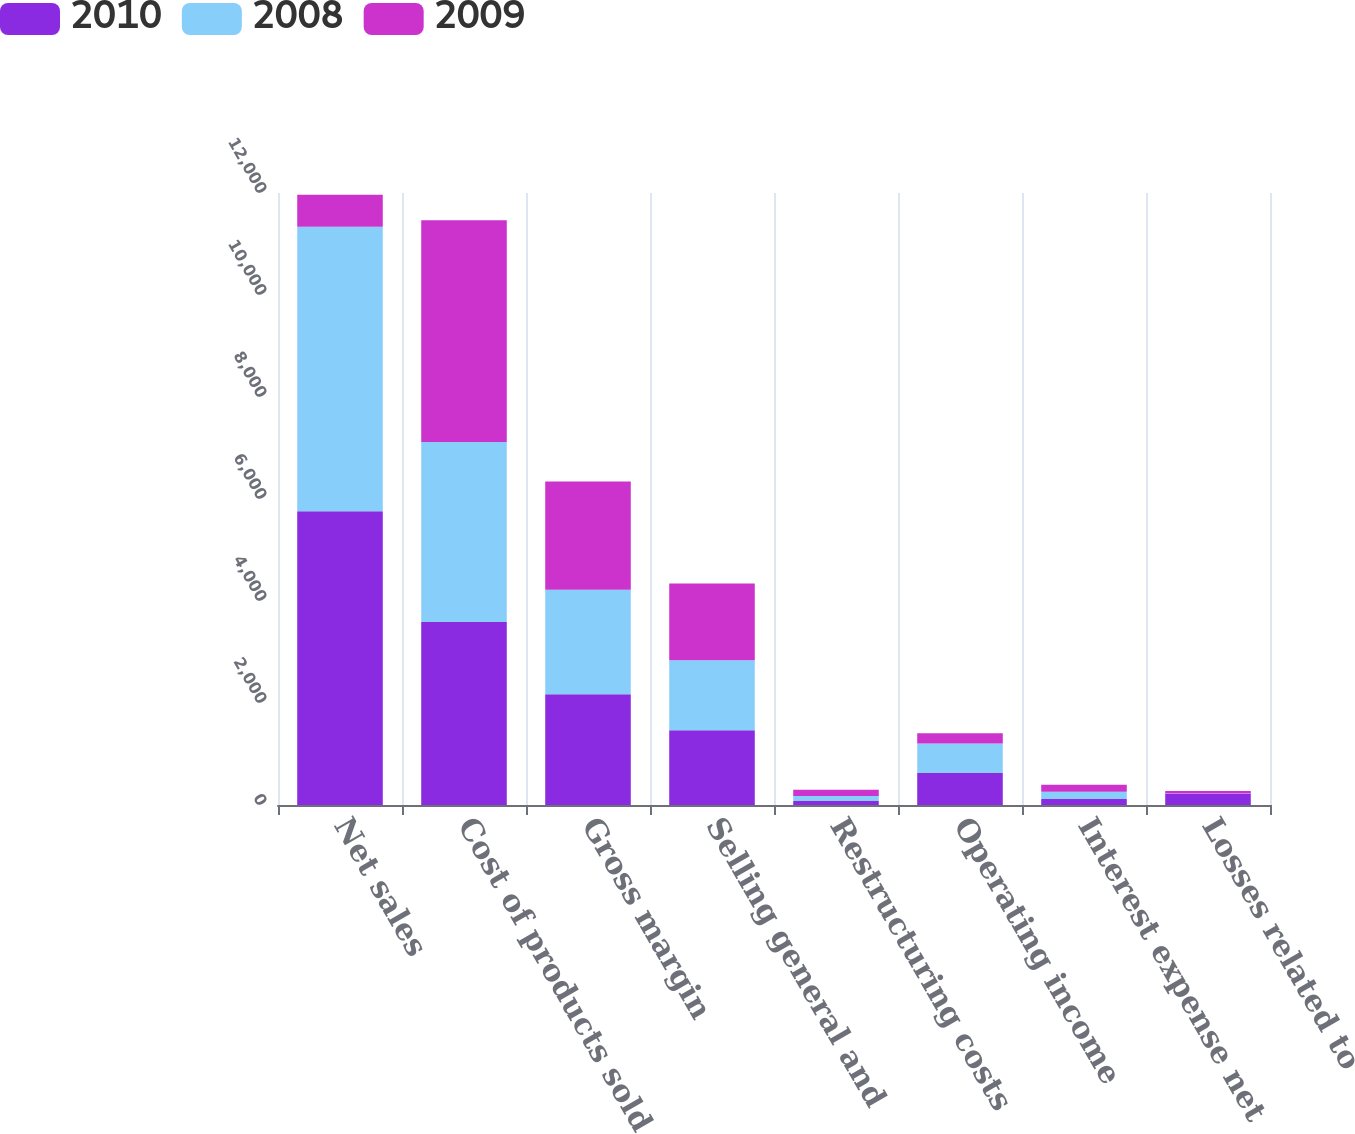Convert chart. <chart><loc_0><loc_0><loc_500><loc_500><stacked_bar_chart><ecel><fcel>Net sales<fcel>Cost of products sold<fcel>Gross margin<fcel>Selling general and<fcel>Restructuring costs<fcel>Operating income<fcel>Interest expense net<fcel>Losses related to<nl><fcel>2010<fcel>5759.2<fcel>3588.4<fcel>2170.8<fcel>1463.4<fcel>77.5<fcel>629.9<fcel>118.4<fcel>218.6<nl><fcel>2008<fcel>5577.6<fcel>3528.1<fcel>2049.5<fcel>1374.6<fcel>100<fcel>574.9<fcel>140<fcel>4.7<nl><fcel>2009<fcel>629.9<fcel>4347.4<fcel>2123.2<fcel>1502.7<fcel>120.3<fcel>200.8<fcel>137.9<fcel>52.2<nl></chart> 